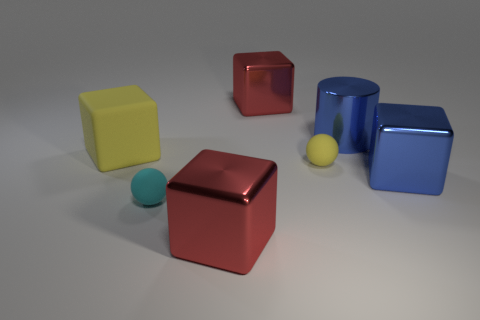Add 1 tiny cyan rubber objects. How many objects exist? 8 Subtract all cylinders. How many objects are left? 6 Subtract all balls. Subtract all tiny yellow matte cylinders. How many objects are left? 5 Add 6 blue objects. How many blue objects are left? 8 Add 6 balls. How many balls exist? 8 Subtract 1 cyan spheres. How many objects are left? 6 